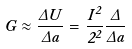<formula> <loc_0><loc_0><loc_500><loc_500>G \approx \frac { \Delta U } { \Delta a } = \frac { I ^ { 2 } } { 2 \Sigma ^ { 2 } } \frac { \Delta \Sigma } { \Delta a }</formula> 